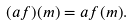Convert formula to latex. <formula><loc_0><loc_0><loc_500><loc_500>( a f ) ( m ) = a f ( m ) .</formula> 